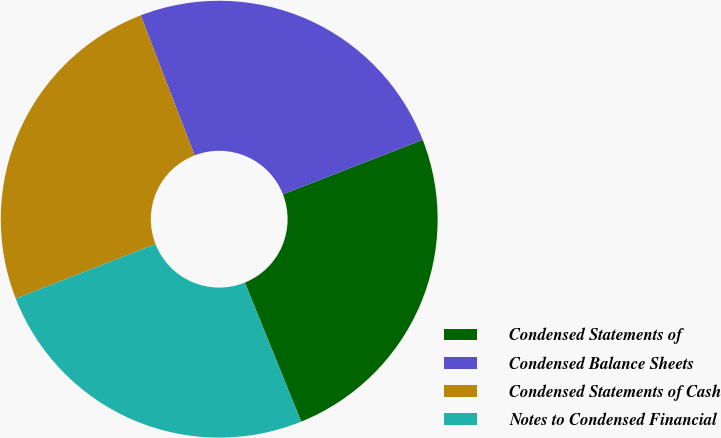Convert chart to OTSL. <chart><loc_0><loc_0><loc_500><loc_500><pie_chart><fcel>Condensed Statements of<fcel>Condensed Balance Sheets<fcel>Condensed Statements of Cash<fcel>Notes to Condensed Financial<nl><fcel>24.8%<fcel>24.93%<fcel>25.07%<fcel>25.2%<nl></chart> 